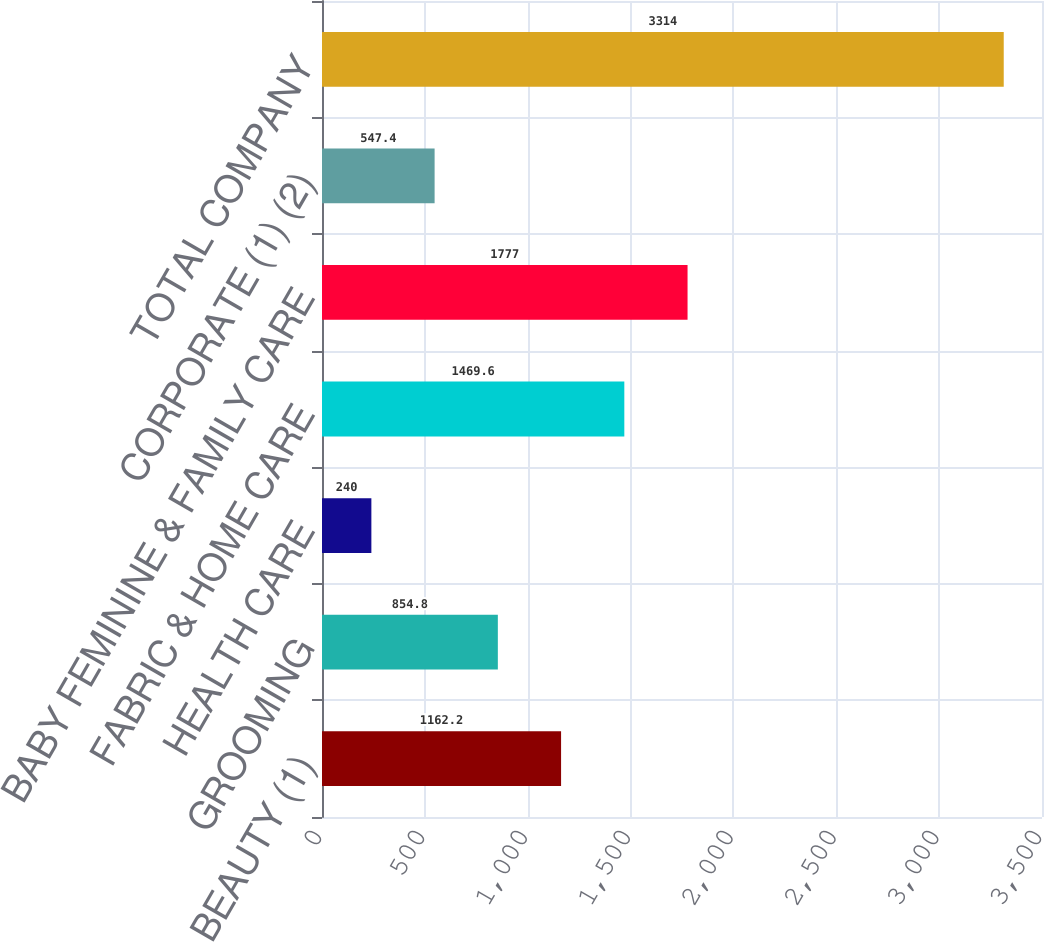Convert chart. <chart><loc_0><loc_0><loc_500><loc_500><bar_chart><fcel>BEAUTY (1)<fcel>GROOMING<fcel>HEALTH CARE<fcel>FABRIC & HOME CARE<fcel>BABY FEMININE & FAMILY CARE<fcel>CORPORATE (1) (2)<fcel>TOTAL COMPANY<nl><fcel>1162.2<fcel>854.8<fcel>240<fcel>1469.6<fcel>1777<fcel>547.4<fcel>3314<nl></chart> 